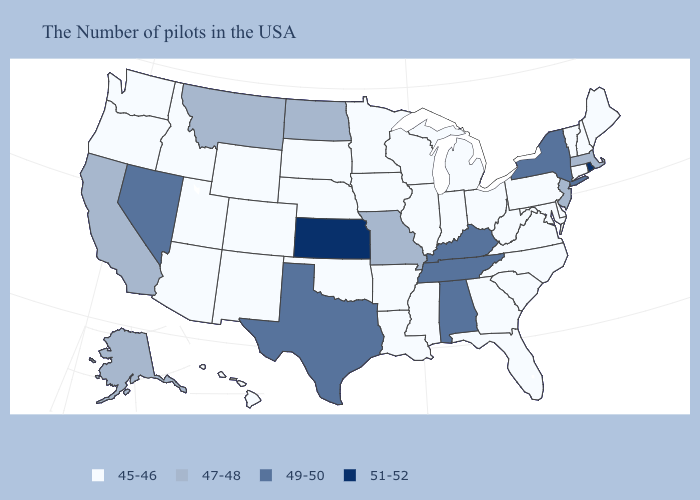What is the value of South Carolina?
Keep it brief. 45-46. What is the highest value in states that border Iowa?
Write a very short answer. 47-48. Does Idaho have a lower value than Oregon?
Short answer required. No. Name the states that have a value in the range 47-48?
Short answer required. Massachusetts, New Jersey, Missouri, North Dakota, Montana, California, Alaska. Name the states that have a value in the range 45-46?
Short answer required. Maine, New Hampshire, Vermont, Connecticut, Delaware, Maryland, Pennsylvania, Virginia, North Carolina, South Carolina, West Virginia, Ohio, Florida, Georgia, Michigan, Indiana, Wisconsin, Illinois, Mississippi, Louisiana, Arkansas, Minnesota, Iowa, Nebraska, Oklahoma, South Dakota, Wyoming, Colorado, New Mexico, Utah, Arizona, Idaho, Washington, Oregon, Hawaii. What is the value of New York?
Short answer required. 49-50. What is the value of Pennsylvania?
Concise answer only. 45-46. Name the states that have a value in the range 45-46?
Keep it brief. Maine, New Hampshire, Vermont, Connecticut, Delaware, Maryland, Pennsylvania, Virginia, North Carolina, South Carolina, West Virginia, Ohio, Florida, Georgia, Michigan, Indiana, Wisconsin, Illinois, Mississippi, Louisiana, Arkansas, Minnesota, Iowa, Nebraska, Oklahoma, South Dakota, Wyoming, Colorado, New Mexico, Utah, Arizona, Idaho, Washington, Oregon, Hawaii. What is the highest value in the USA?
Answer briefly. 51-52. What is the lowest value in the USA?
Answer briefly. 45-46. What is the lowest value in states that border South Dakota?
Concise answer only. 45-46. Which states have the lowest value in the USA?
Quick response, please. Maine, New Hampshire, Vermont, Connecticut, Delaware, Maryland, Pennsylvania, Virginia, North Carolina, South Carolina, West Virginia, Ohio, Florida, Georgia, Michigan, Indiana, Wisconsin, Illinois, Mississippi, Louisiana, Arkansas, Minnesota, Iowa, Nebraska, Oklahoma, South Dakota, Wyoming, Colorado, New Mexico, Utah, Arizona, Idaho, Washington, Oregon, Hawaii. Name the states that have a value in the range 51-52?
Keep it brief. Rhode Island, Kansas. Name the states that have a value in the range 51-52?
Keep it brief. Rhode Island, Kansas. 